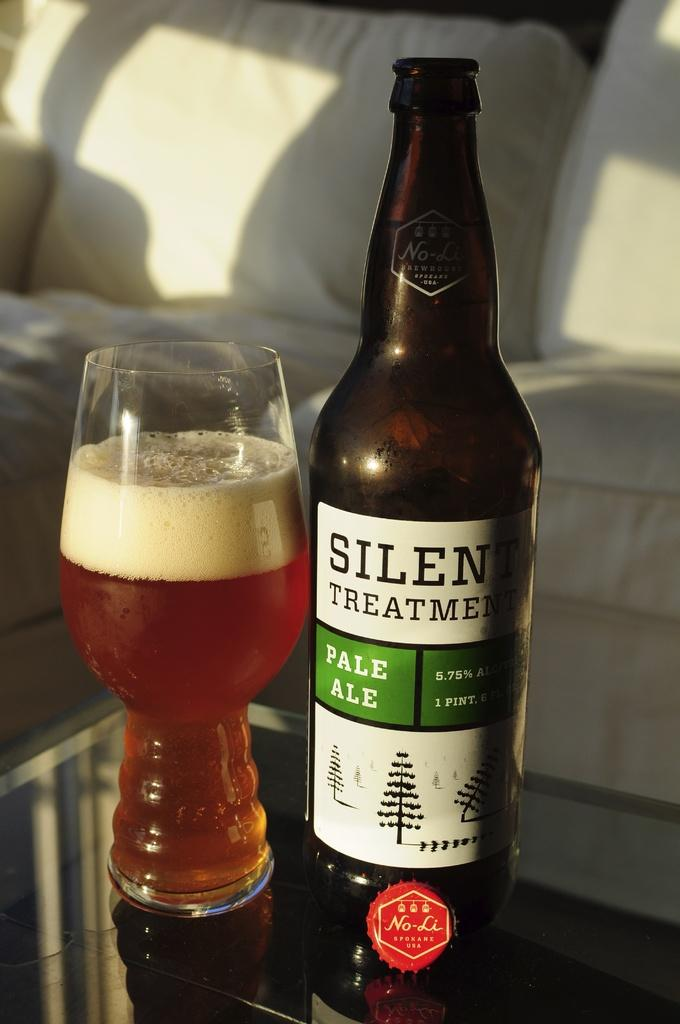<image>
Create a compact narrative representing the image presented. A bottle of pale ale is on a table with a glass next to it. 